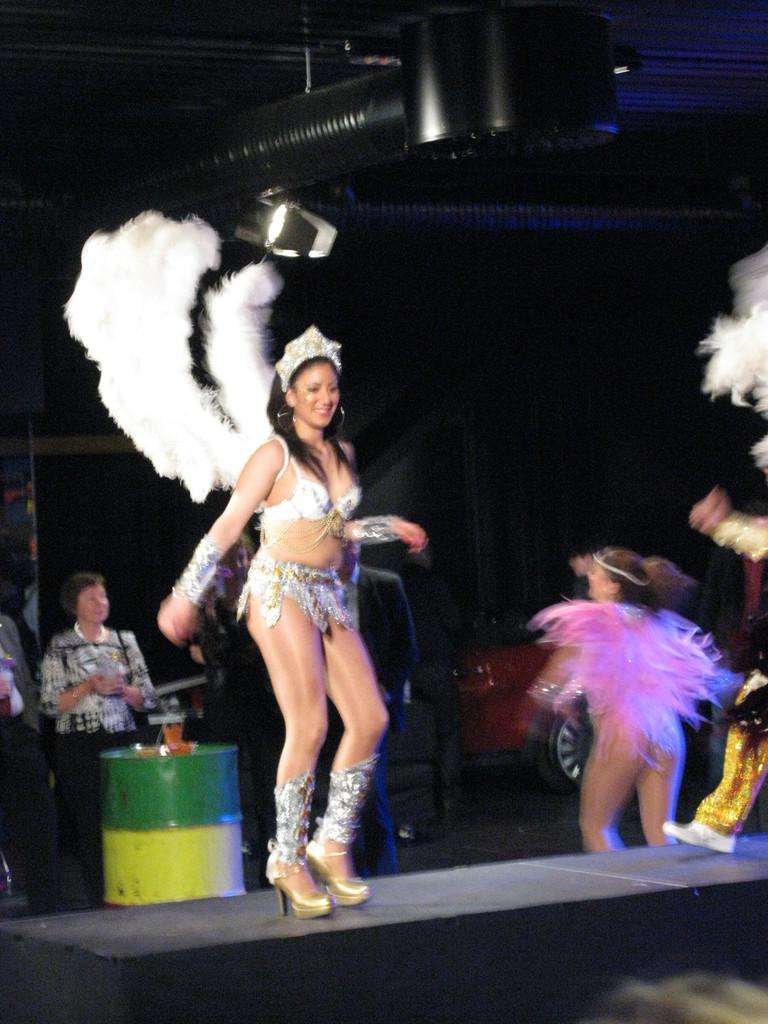Who are the main subjects in the image? There are two ladies in the center of the image. What are the ladies wearing? The ladies are wearing costumes. What are the ladies doing in the image? The ladies are dancing. Can you describe the people on the left side of the image? There are people standing on the left side of the image. What can be seen in the background of the image? There is a car, a drum, and a stage in the background of the image. What type of ornament is hanging from the car in the image? There is no ornament hanging from the car in the image. How many screws can be seen on the stage in the image? There is no mention of screws in the image, and it is not possible to count them from the provided facts. 